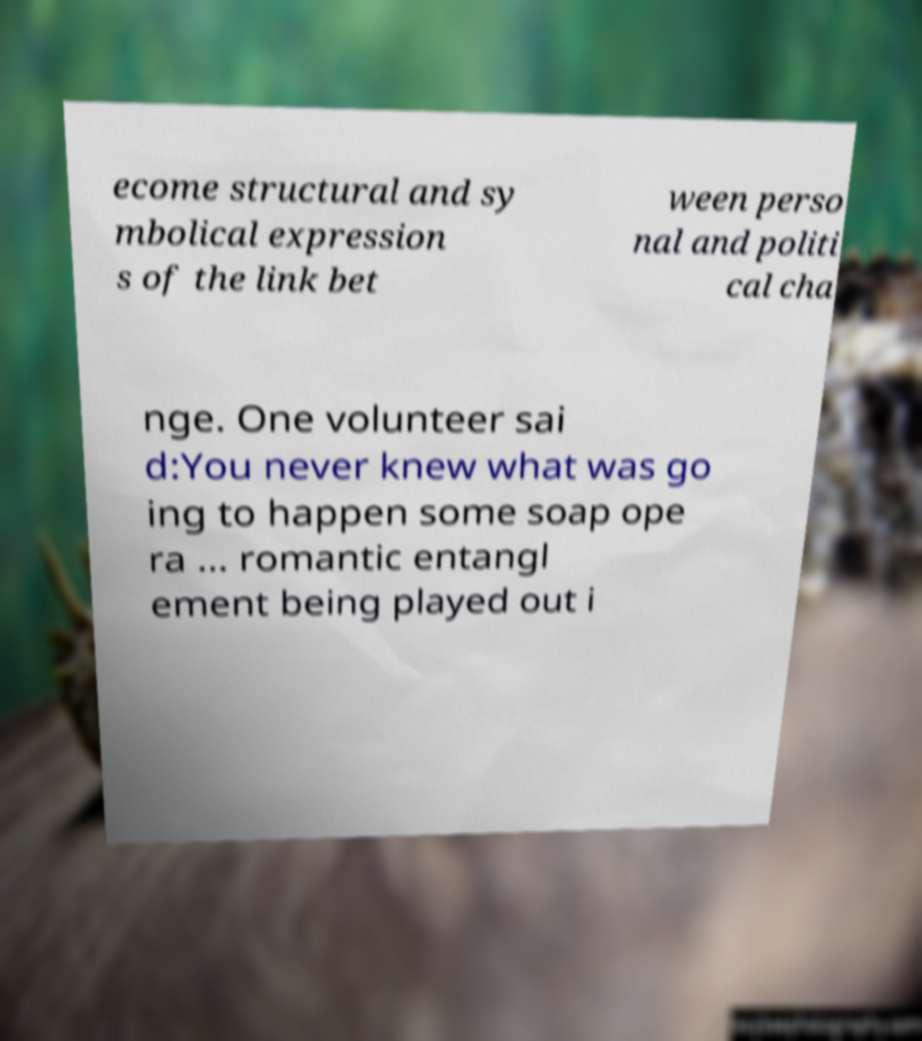Please identify and transcribe the text found in this image. ecome structural and sy mbolical expression s of the link bet ween perso nal and politi cal cha nge. One volunteer sai d:You never knew what was go ing to happen some soap ope ra ... romantic entangl ement being played out i 